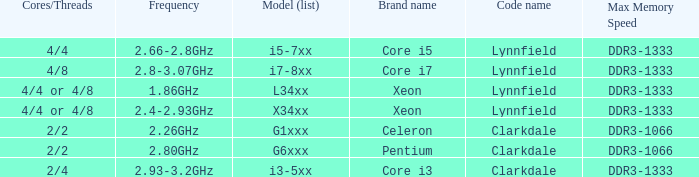What frequency does model L34xx use? 1.86GHz. Give me the full table as a dictionary. {'header': ['Cores/Threads', 'Frequency', 'Model (list)', 'Brand name', 'Code name', 'Max Memory Speed'], 'rows': [['4/4', '2.66-2.8GHz', 'i5-7xx', 'Core i5', 'Lynnfield', 'DDR3-1333'], ['4/8', '2.8-3.07GHz', 'i7-8xx', 'Core i7', 'Lynnfield', 'DDR3-1333'], ['4/4 or 4/8', '1.86GHz', 'L34xx', 'Xeon', 'Lynnfield', 'DDR3-1333'], ['4/4 or 4/8', '2.4-2.93GHz', 'X34xx', 'Xeon', 'Lynnfield', 'DDR3-1333'], ['2/2', '2.26GHz', 'G1xxx', 'Celeron', 'Clarkdale', 'DDR3-1066'], ['2/2', '2.80GHz', 'G6xxx', 'Pentium', 'Clarkdale', 'DDR3-1066'], ['2/4', '2.93-3.2GHz', 'i3-5xx', 'Core i3', 'Clarkdale', 'DDR3-1333']]} 